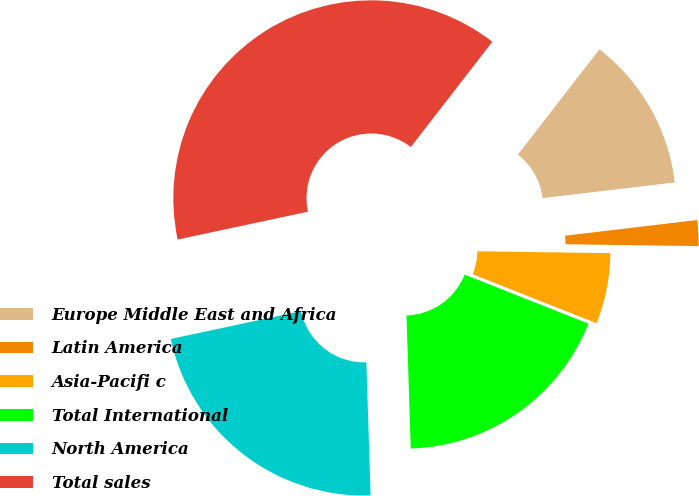<chart> <loc_0><loc_0><loc_500><loc_500><pie_chart><fcel>Europe Middle East and Africa<fcel>Latin America<fcel>Asia-Pacifi c<fcel>Total International<fcel>North America<fcel>Total sales<nl><fcel>12.63%<fcel>2.1%<fcel>5.78%<fcel>18.49%<fcel>22.16%<fcel>38.83%<nl></chart> 